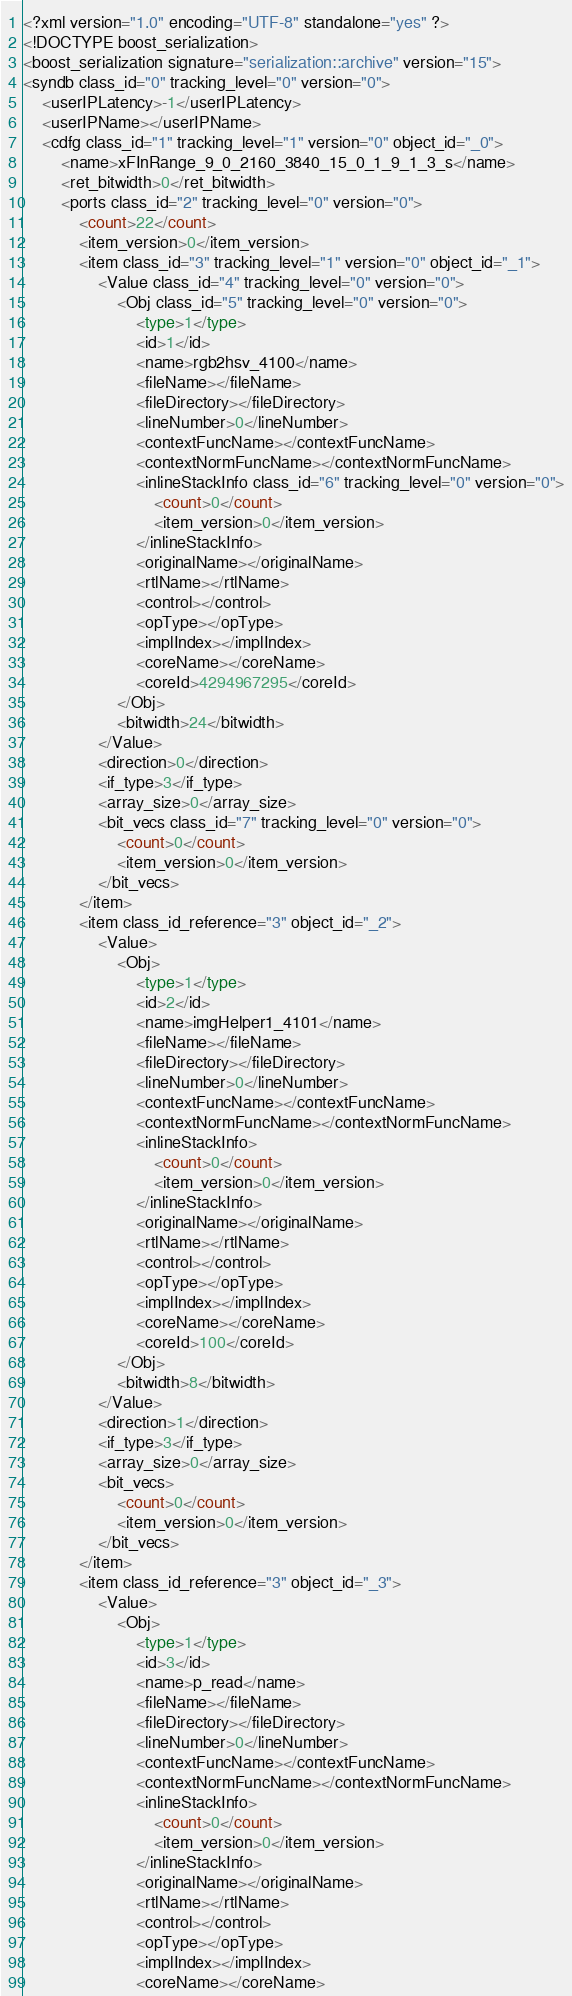<code> <loc_0><loc_0><loc_500><loc_500><_Ada_><?xml version="1.0" encoding="UTF-8" standalone="yes" ?>
<!DOCTYPE boost_serialization>
<boost_serialization signature="serialization::archive" version="15">
<syndb class_id="0" tracking_level="0" version="0">
	<userIPLatency>-1</userIPLatency>
	<userIPName></userIPName>
	<cdfg class_id="1" tracking_level="1" version="0" object_id="_0">
		<name>xFInRange_9_0_2160_3840_15_0_1_9_1_3_s</name>
		<ret_bitwidth>0</ret_bitwidth>
		<ports class_id="2" tracking_level="0" version="0">
			<count>22</count>
			<item_version>0</item_version>
			<item class_id="3" tracking_level="1" version="0" object_id="_1">
				<Value class_id="4" tracking_level="0" version="0">
					<Obj class_id="5" tracking_level="0" version="0">
						<type>1</type>
						<id>1</id>
						<name>rgb2hsv_4100</name>
						<fileName></fileName>
						<fileDirectory></fileDirectory>
						<lineNumber>0</lineNumber>
						<contextFuncName></contextFuncName>
						<contextNormFuncName></contextNormFuncName>
						<inlineStackInfo class_id="6" tracking_level="0" version="0">
							<count>0</count>
							<item_version>0</item_version>
						</inlineStackInfo>
						<originalName></originalName>
						<rtlName></rtlName>
						<control></control>
						<opType></opType>
						<implIndex></implIndex>
						<coreName></coreName>
						<coreId>4294967295</coreId>
					</Obj>
					<bitwidth>24</bitwidth>
				</Value>
				<direction>0</direction>
				<if_type>3</if_type>
				<array_size>0</array_size>
				<bit_vecs class_id="7" tracking_level="0" version="0">
					<count>0</count>
					<item_version>0</item_version>
				</bit_vecs>
			</item>
			<item class_id_reference="3" object_id="_2">
				<Value>
					<Obj>
						<type>1</type>
						<id>2</id>
						<name>imgHelper1_4101</name>
						<fileName></fileName>
						<fileDirectory></fileDirectory>
						<lineNumber>0</lineNumber>
						<contextFuncName></contextFuncName>
						<contextNormFuncName></contextNormFuncName>
						<inlineStackInfo>
							<count>0</count>
							<item_version>0</item_version>
						</inlineStackInfo>
						<originalName></originalName>
						<rtlName></rtlName>
						<control></control>
						<opType></opType>
						<implIndex></implIndex>
						<coreName></coreName>
						<coreId>100</coreId>
					</Obj>
					<bitwidth>8</bitwidth>
				</Value>
				<direction>1</direction>
				<if_type>3</if_type>
				<array_size>0</array_size>
				<bit_vecs>
					<count>0</count>
					<item_version>0</item_version>
				</bit_vecs>
			</item>
			<item class_id_reference="3" object_id="_3">
				<Value>
					<Obj>
						<type>1</type>
						<id>3</id>
						<name>p_read</name>
						<fileName></fileName>
						<fileDirectory></fileDirectory>
						<lineNumber>0</lineNumber>
						<contextFuncName></contextFuncName>
						<contextNormFuncName></contextNormFuncName>
						<inlineStackInfo>
							<count>0</count>
							<item_version>0</item_version>
						</inlineStackInfo>
						<originalName></originalName>
						<rtlName></rtlName>
						<control></control>
						<opType></opType>
						<implIndex></implIndex>
						<coreName></coreName></code> 